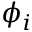Convert formula to latex. <formula><loc_0><loc_0><loc_500><loc_500>\phi _ { i }</formula> 